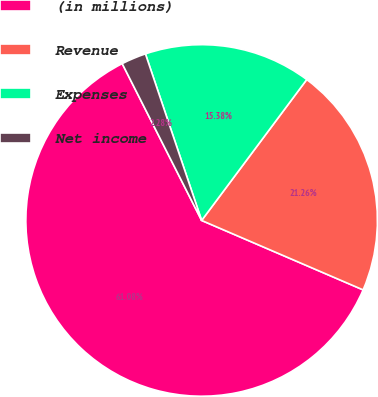Convert chart to OTSL. <chart><loc_0><loc_0><loc_500><loc_500><pie_chart><fcel>(in millions)<fcel>Revenue<fcel>Expenses<fcel>Net income<nl><fcel>61.07%<fcel>21.26%<fcel>15.38%<fcel>2.28%<nl></chart> 